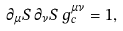<formula> <loc_0><loc_0><loc_500><loc_500>\partial _ { \mu } S \, \partial _ { \nu } S \, g ^ { \mu \nu } _ { c } = 1 ,</formula> 